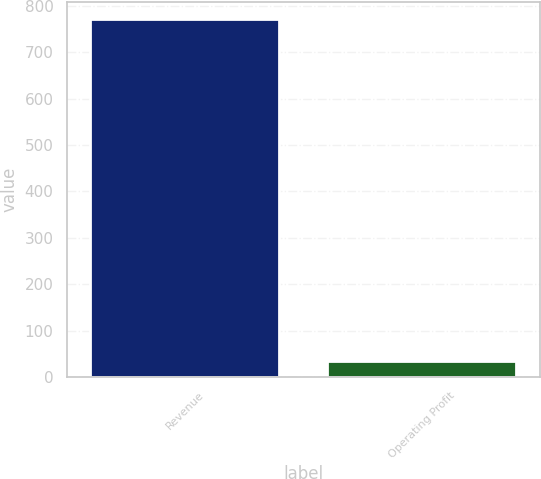Convert chart to OTSL. <chart><loc_0><loc_0><loc_500><loc_500><bar_chart><fcel>Revenue<fcel>Operating Profit<nl><fcel>770.6<fcel>34<nl></chart> 